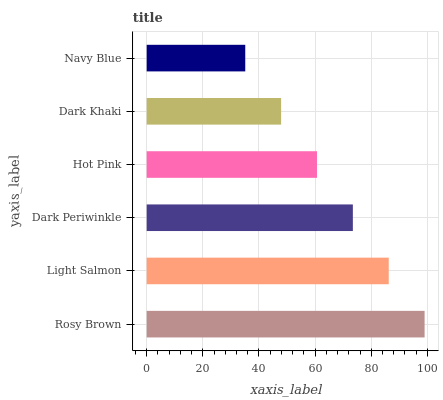Is Navy Blue the minimum?
Answer yes or no. Yes. Is Rosy Brown the maximum?
Answer yes or no. Yes. Is Light Salmon the minimum?
Answer yes or no. No. Is Light Salmon the maximum?
Answer yes or no. No. Is Rosy Brown greater than Light Salmon?
Answer yes or no. Yes. Is Light Salmon less than Rosy Brown?
Answer yes or no. Yes. Is Light Salmon greater than Rosy Brown?
Answer yes or no. No. Is Rosy Brown less than Light Salmon?
Answer yes or no. No. Is Dark Periwinkle the high median?
Answer yes or no. Yes. Is Hot Pink the low median?
Answer yes or no. Yes. Is Light Salmon the high median?
Answer yes or no. No. Is Dark Khaki the low median?
Answer yes or no. No. 